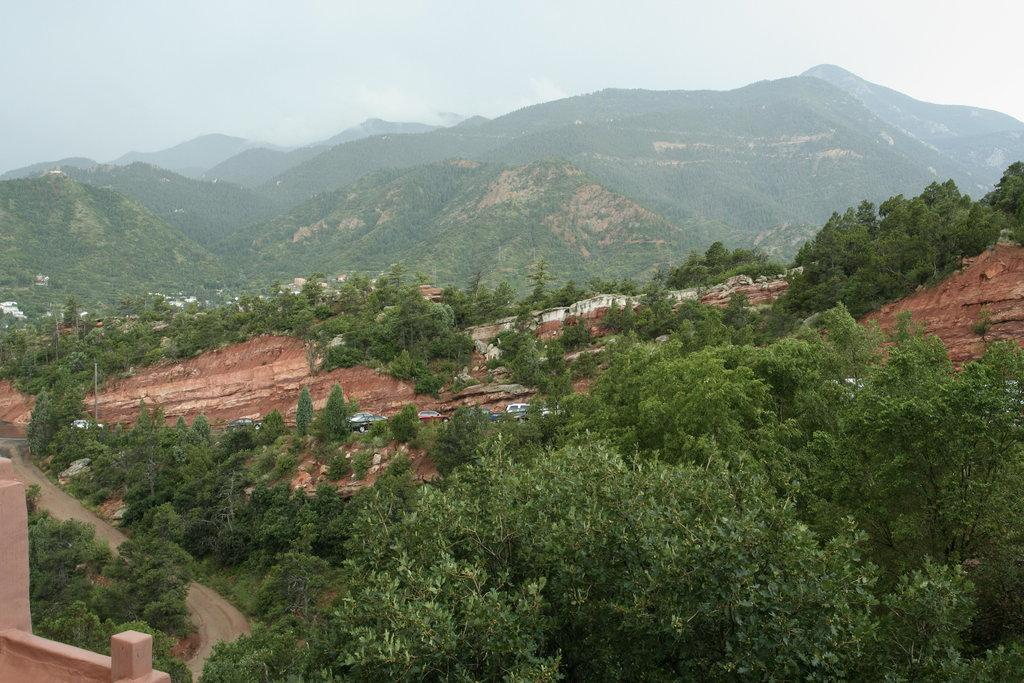What geographical feature is visible in the image? There are mountains in the image. What is covering the mountains in the image? The mountains are covered with trees. What page of the book does the actor turn in the image? There is no book or actor present in the image; it features mountains covered with trees. 